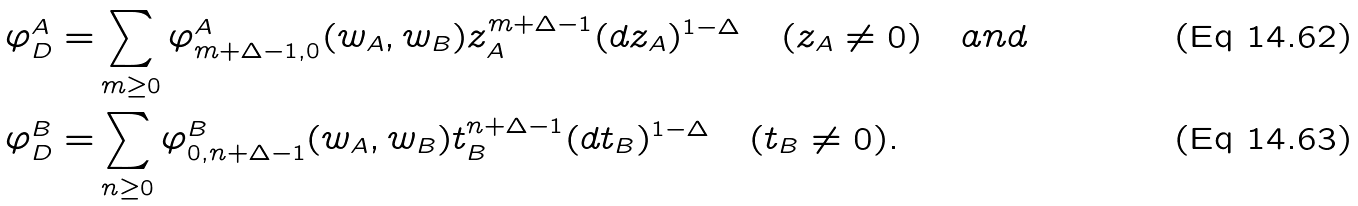Convert formula to latex. <formula><loc_0><loc_0><loc_500><loc_500>\varphi _ { D } ^ { A } = & \sum _ { m \geq 0 } \varphi _ { m + \Delta - 1 , 0 } ^ { A } ( w _ { A } , w _ { B } ) z _ { A } ^ { m + \Delta - 1 } ( d z _ { A } ) ^ { 1 - \Delta } \quad ( z _ { A } \neq 0 ) \quad a n d \\ \varphi _ { D } ^ { B } = & \sum _ { n \geq 0 } \varphi _ { 0 , n + \Delta - 1 } ^ { B } ( w _ { A } , w _ { B } ) t _ { B } ^ { n + \Delta - 1 } ( d t _ { B } ) ^ { 1 - \Delta } \quad ( t _ { B } \neq 0 ) .</formula> 